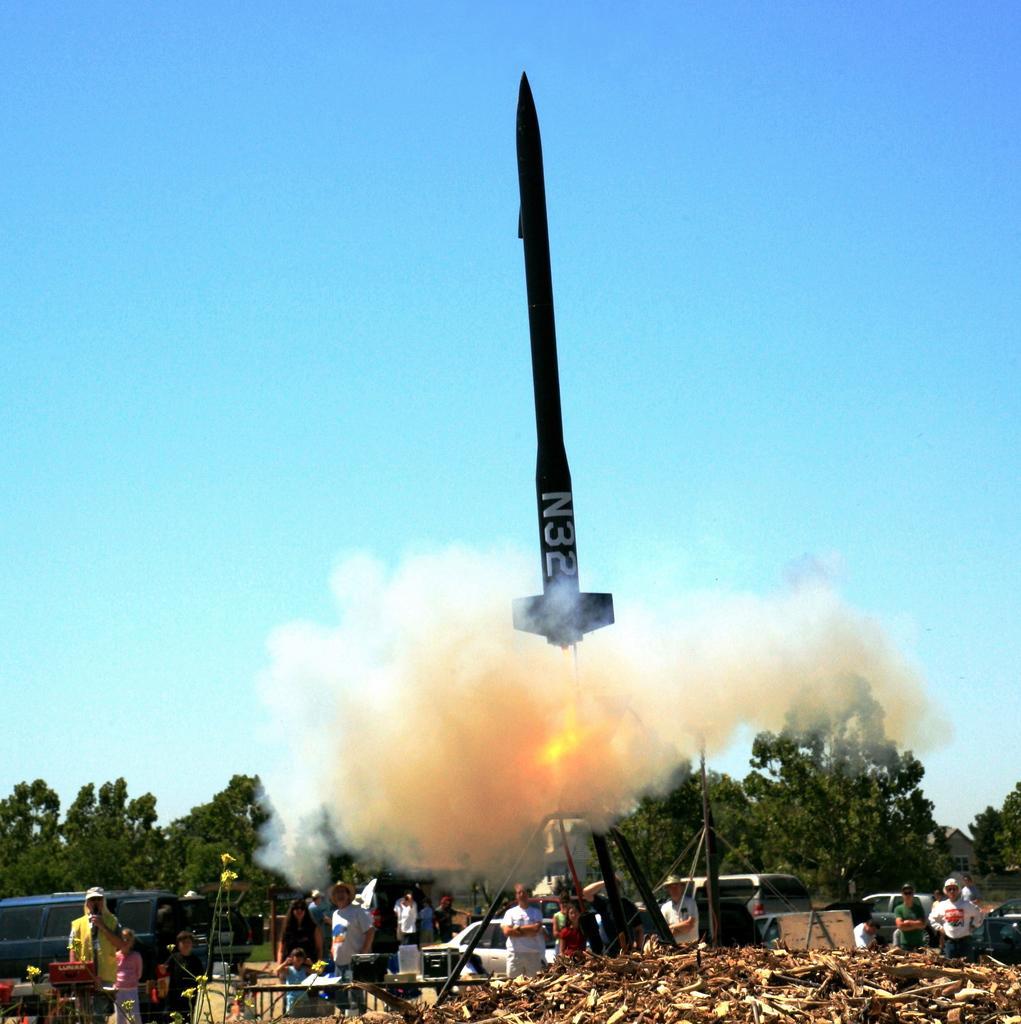Please provide a concise description of this image. In this image there is a rocket, smoke, trees, vehicles, people, table, sky and objects. 